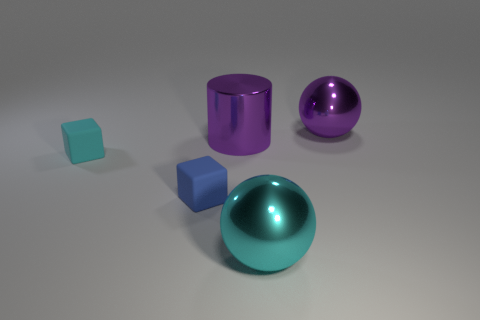Does the large purple cylinder have the same material as the large purple ball? yes 